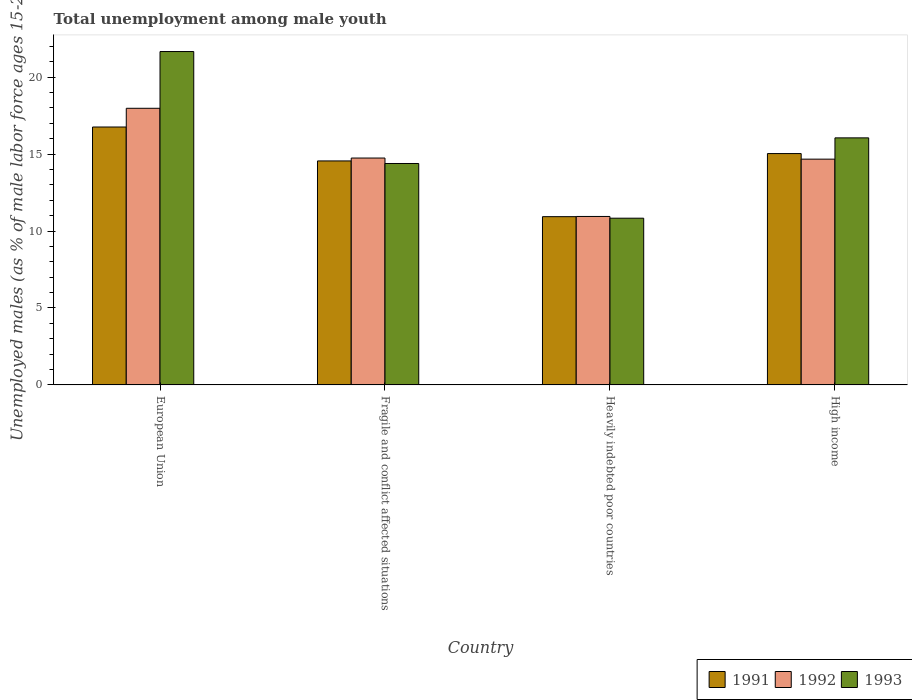How many different coloured bars are there?
Offer a very short reply. 3. Are the number of bars on each tick of the X-axis equal?
Your answer should be compact. Yes. What is the label of the 3rd group of bars from the left?
Make the answer very short. Heavily indebted poor countries. In how many cases, is the number of bars for a given country not equal to the number of legend labels?
Provide a succinct answer. 0. What is the percentage of unemployed males in in 1991 in Heavily indebted poor countries?
Give a very brief answer. 10.94. Across all countries, what is the maximum percentage of unemployed males in in 1991?
Provide a succinct answer. 16.76. Across all countries, what is the minimum percentage of unemployed males in in 1992?
Offer a terse response. 10.95. In which country was the percentage of unemployed males in in 1993 minimum?
Keep it short and to the point. Heavily indebted poor countries. What is the total percentage of unemployed males in in 1993 in the graph?
Offer a terse response. 62.96. What is the difference between the percentage of unemployed males in in 1993 in European Union and that in Heavily indebted poor countries?
Provide a short and direct response. 10.83. What is the difference between the percentage of unemployed males in in 1992 in High income and the percentage of unemployed males in in 1993 in Fragile and conflict affected situations?
Your answer should be compact. 0.28. What is the average percentage of unemployed males in in 1993 per country?
Ensure brevity in your answer.  15.74. What is the difference between the percentage of unemployed males in of/in 1992 and percentage of unemployed males in of/in 1991 in High income?
Offer a very short reply. -0.36. What is the ratio of the percentage of unemployed males in in 1991 in Fragile and conflict affected situations to that in Heavily indebted poor countries?
Offer a terse response. 1.33. Is the difference between the percentage of unemployed males in in 1992 in European Union and High income greater than the difference between the percentage of unemployed males in in 1991 in European Union and High income?
Your answer should be compact. Yes. What is the difference between the highest and the second highest percentage of unemployed males in in 1991?
Offer a very short reply. 2.2. What is the difference between the highest and the lowest percentage of unemployed males in in 1991?
Your answer should be compact. 5.83. In how many countries, is the percentage of unemployed males in in 1991 greater than the average percentage of unemployed males in in 1991 taken over all countries?
Ensure brevity in your answer.  3. Is the sum of the percentage of unemployed males in in 1993 in Fragile and conflict affected situations and High income greater than the maximum percentage of unemployed males in in 1991 across all countries?
Offer a terse response. Yes. What does the 3rd bar from the left in European Union represents?
Offer a very short reply. 1993. Is it the case that in every country, the sum of the percentage of unemployed males in in 1993 and percentage of unemployed males in in 1991 is greater than the percentage of unemployed males in in 1992?
Make the answer very short. Yes. Are all the bars in the graph horizontal?
Provide a short and direct response. No. What is the difference between two consecutive major ticks on the Y-axis?
Your answer should be very brief. 5. Where does the legend appear in the graph?
Give a very brief answer. Bottom right. How are the legend labels stacked?
Your answer should be compact. Horizontal. What is the title of the graph?
Your answer should be very brief. Total unemployment among male youth. What is the label or title of the X-axis?
Keep it short and to the point. Country. What is the label or title of the Y-axis?
Give a very brief answer. Unemployed males (as % of male labor force ages 15-24). What is the Unemployed males (as % of male labor force ages 15-24) of 1991 in European Union?
Offer a terse response. 16.76. What is the Unemployed males (as % of male labor force ages 15-24) of 1992 in European Union?
Your answer should be very brief. 17.98. What is the Unemployed males (as % of male labor force ages 15-24) in 1993 in European Union?
Provide a succinct answer. 21.67. What is the Unemployed males (as % of male labor force ages 15-24) in 1991 in Fragile and conflict affected situations?
Your answer should be compact. 14.56. What is the Unemployed males (as % of male labor force ages 15-24) of 1992 in Fragile and conflict affected situations?
Ensure brevity in your answer.  14.75. What is the Unemployed males (as % of male labor force ages 15-24) of 1993 in Fragile and conflict affected situations?
Ensure brevity in your answer.  14.39. What is the Unemployed males (as % of male labor force ages 15-24) of 1991 in Heavily indebted poor countries?
Your answer should be very brief. 10.94. What is the Unemployed males (as % of male labor force ages 15-24) of 1992 in Heavily indebted poor countries?
Provide a succinct answer. 10.95. What is the Unemployed males (as % of male labor force ages 15-24) in 1993 in Heavily indebted poor countries?
Offer a terse response. 10.84. What is the Unemployed males (as % of male labor force ages 15-24) of 1991 in High income?
Your answer should be compact. 15.04. What is the Unemployed males (as % of male labor force ages 15-24) in 1992 in High income?
Offer a terse response. 14.67. What is the Unemployed males (as % of male labor force ages 15-24) of 1993 in High income?
Provide a short and direct response. 16.06. Across all countries, what is the maximum Unemployed males (as % of male labor force ages 15-24) in 1991?
Make the answer very short. 16.76. Across all countries, what is the maximum Unemployed males (as % of male labor force ages 15-24) of 1992?
Your answer should be compact. 17.98. Across all countries, what is the maximum Unemployed males (as % of male labor force ages 15-24) of 1993?
Give a very brief answer. 21.67. Across all countries, what is the minimum Unemployed males (as % of male labor force ages 15-24) of 1991?
Provide a succinct answer. 10.94. Across all countries, what is the minimum Unemployed males (as % of male labor force ages 15-24) in 1992?
Keep it short and to the point. 10.95. Across all countries, what is the minimum Unemployed males (as % of male labor force ages 15-24) of 1993?
Your response must be concise. 10.84. What is the total Unemployed males (as % of male labor force ages 15-24) in 1991 in the graph?
Provide a succinct answer. 57.3. What is the total Unemployed males (as % of male labor force ages 15-24) of 1992 in the graph?
Ensure brevity in your answer.  58.35. What is the total Unemployed males (as % of male labor force ages 15-24) of 1993 in the graph?
Your answer should be very brief. 62.96. What is the difference between the Unemployed males (as % of male labor force ages 15-24) of 1991 in European Union and that in Fragile and conflict affected situations?
Offer a terse response. 2.2. What is the difference between the Unemployed males (as % of male labor force ages 15-24) in 1992 in European Union and that in Fragile and conflict affected situations?
Your answer should be very brief. 3.23. What is the difference between the Unemployed males (as % of male labor force ages 15-24) of 1993 in European Union and that in Fragile and conflict affected situations?
Your response must be concise. 7.28. What is the difference between the Unemployed males (as % of male labor force ages 15-24) of 1991 in European Union and that in Heavily indebted poor countries?
Your answer should be very brief. 5.83. What is the difference between the Unemployed males (as % of male labor force ages 15-24) of 1992 in European Union and that in Heavily indebted poor countries?
Offer a terse response. 7.03. What is the difference between the Unemployed males (as % of male labor force ages 15-24) of 1993 in European Union and that in Heavily indebted poor countries?
Give a very brief answer. 10.83. What is the difference between the Unemployed males (as % of male labor force ages 15-24) in 1991 in European Union and that in High income?
Keep it short and to the point. 1.73. What is the difference between the Unemployed males (as % of male labor force ages 15-24) in 1992 in European Union and that in High income?
Your answer should be very brief. 3.31. What is the difference between the Unemployed males (as % of male labor force ages 15-24) in 1993 in European Union and that in High income?
Make the answer very short. 5.61. What is the difference between the Unemployed males (as % of male labor force ages 15-24) of 1991 in Fragile and conflict affected situations and that in Heavily indebted poor countries?
Your answer should be very brief. 3.62. What is the difference between the Unemployed males (as % of male labor force ages 15-24) of 1992 in Fragile and conflict affected situations and that in Heavily indebted poor countries?
Provide a succinct answer. 3.8. What is the difference between the Unemployed males (as % of male labor force ages 15-24) of 1993 in Fragile and conflict affected situations and that in Heavily indebted poor countries?
Your answer should be very brief. 3.56. What is the difference between the Unemployed males (as % of male labor force ages 15-24) of 1991 in Fragile and conflict affected situations and that in High income?
Your response must be concise. -0.48. What is the difference between the Unemployed males (as % of male labor force ages 15-24) in 1992 in Fragile and conflict affected situations and that in High income?
Your response must be concise. 0.07. What is the difference between the Unemployed males (as % of male labor force ages 15-24) in 1993 in Fragile and conflict affected situations and that in High income?
Provide a succinct answer. -1.67. What is the difference between the Unemployed males (as % of male labor force ages 15-24) in 1991 in Heavily indebted poor countries and that in High income?
Offer a very short reply. -4.1. What is the difference between the Unemployed males (as % of male labor force ages 15-24) in 1992 in Heavily indebted poor countries and that in High income?
Ensure brevity in your answer.  -3.72. What is the difference between the Unemployed males (as % of male labor force ages 15-24) of 1993 in Heavily indebted poor countries and that in High income?
Provide a succinct answer. -5.22. What is the difference between the Unemployed males (as % of male labor force ages 15-24) in 1991 in European Union and the Unemployed males (as % of male labor force ages 15-24) in 1992 in Fragile and conflict affected situations?
Provide a succinct answer. 2.02. What is the difference between the Unemployed males (as % of male labor force ages 15-24) of 1991 in European Union and the Unemployed males (as % of male labor force ages 15-24) of 1993 in Fragile and conflict affected situations?
Provide a succinct answer. 2.37. What is the difference between the Unemployed males (as % of male labor force ages 15-24) in 1992 in European Union and the Unemployed males (as % of male labor force ages 15-24) in 1993 in Fragile and conflict affected situations?
Your response must be concise. 3.59. What is the difference between the Unemployed males (as % of male labor force ages 15-24) of 1991 in European Union and the Unemployed males (as % of male labor force ages 15-24) of 1992 in Heavily indebted poor countries?
Offer a very short reply. 5.81. What is the difference between the Unemployed males (as % of male labor force ages 15-24) of 1991 in European Union and the Unemployed males (as % of male labor force ages 15-24) of 1993 in Heavily indebted poor countries?
Your answer should be very brief. 5.93. What is the difference between the Unemployed males (as % of male labor force ages 15-24) of 1992 in European Union and the Unemployed males (as % of male labor force ages 15-24) of 1993 in Heavily indebted poor countries?
Provide a short and direct response. 7.14. What is the difference between the Unemployed males (as % of male labor force ages 15-24) of 1991 in European Union and the Unemployed males (as % of male labor force ages 15-24) of 1992 in High income?
Make the answer very short. 2.09. What is the difference between the Unemployed males (as % of male labor force ages 15-24) in 1991 in European Union and the Unemployed males (as % of male labor force ages 15-24) in 1993 in High income?
Make the answer very short. 0.71. What is the difference between the Unemployed males (as % of male labor force ages 15-24) in 1992 in European Union and the Unemployed males (as % of male labor force ages 15-24) in 1993 in High income?
Provide a short and direct response. 1.92. What is the difference between the Unemployed males (as % of male labor force ages 15-24) of 1991 in Fragile and conflict affected situations and the Unemployed males (as % of male labor force ages 15-24) of 1992 in Heavily indebted poor countries?
Your answer should be very brief. 3.61. What is the difference between the Unemployed males (as % of male labor force ages 15-24) in 1991 in Fragile and conflict affected situations and the Unemployed males (as % of male labor force ages 15-24) in 1993 in Heavily indebted poor countries?
Your answer should be very brief. 3.72. What is the difference between the Unemployed males (as % of male labor force ages 15-24) of 1992 in Fragile and conflict affected situations and the Unemployed males (as % of male labor force ages 15-24) of 1993 in Heavily indebted poor countries?
Provide a succinct answer. 3.91. What is the difference between the Unemployed males (as % of male labor force ages 15-24) in 1991 in Fragile and conflict affected situations and the Unemployed males (as % of male labor force ages 15-24) in 1992 in High income?
Your answer should be compact. -0.12. What is the difference between the Unemployed males (as % of male labor force ages 15-24) of 1991 in Fragile and conflict affected situations and the Unemployed males (as % of male labor force ages 15-24) of 1993 in High income?
Ensure brevity in your answer.  -1.5. What is the difference between the Unemployed males (as % of male labor force ages 15-24) of 1992 in Fragile and conflict affected situations and the Unemployed males (as % of male labor force ages 15-24) of 1993 in High income?
Ensure brevity in your answer.  -1.31. What is the difference between the Unemployed males (as % of male labor force ages 15-24) of 1991 in Heavily indebted poor countries and the Unemployed males (as % of male labor force ages 15-24) of 1992 in High income?
Keep it short and to the point. -3.74. What is the difference between the Unemployed males (as % of male labor force ages 15-24) of 1991 in Heavily indebted poor countries and the Unemployed males (as % of male labor force ages 15-24) of 1993 in High income?
Give a very brief answer. -5.12. What is the difference between the Unemployed males (as % of male labor force ages 15-24) in 1992 in Heavily indebted poor countries and the Unemployed males (as % of male labor force ages 15-24) in 1993 in High income?
Ensure brevity in your answer.  -5.11. What is the average Unemployed males (as % of male labor force ages 15-24) in 1991 per country?
Your answer should be compact. 14.32. What is the average Unemployed males (as % of male labor force ages 15-24) of 1992 per country?
Provide a succinct answer. 14.59. What is the average Unemployed males (as % of male labor force ages 15-24) of 1993 per country?
Your answer should be very brief. 15.74. What is the difference between the Unemployed males (as % of male labor force ages 15-24) of 1991 and Unemployed males (as % of male labor force ages 15-24) of 1992 in European Union?
Keep it short and to the point. -1.22. What is the difference between the Unemployed males (as % of male labor force ages 15-24) in 1991 and Unemployed males (as % of male labor force ages 15-24) in 1993 in European Union?
Ensure brevity in your answer.  -4.91. What is the difference between the Unemployed males (as % of male labor force ages 15-24) in 1992 and Unemployed males (as % of male labor force ages 15-24) in 1993 in European Union?
Ensure brevity in your answer.  -3.69. What is the difference between the Unemployed males (as % of male labor force ages 15-24) in 1991 and Unemployed males (as % of male labor force ages 15-24) in 1992 in Fragile and conflict affected situations?
Your response must be concise. -0.19. What is the difference between the Unemployed males (as % of male labor force ages 15-24) in 1991 and Unemployed males (as % of male labor force ages 15-24) in 1993 in Fragile and conflict affected situations?
Offer a terse response. 0.17. What is the difference between the Unemployed males (as % of male labor force ages 15-24) in 1992 and Unemployed males (as % of male labor force ages 15-24) in 1993 in Fragile and conflict affected situations?
Offer a very short reply. 0.36. What is the difference between the Unemployed males (as % of male labor force ages 15-24) in 1991 and Unemployed males (as % of male labor force ages 15-24) in 1992 in Heavily indebted poor countries?
Provide a succinct answer. -0.01. What is the difference between the Unemployed males (as % of male labor force ages 15-24) in 1991 and Unemployed males (as % of male labor force ages 15-24) in 1993 in Heavily indebted poor countries?
Your answer should be compact. 0.1. What is the difference between the Unemployed males (as % of male labor force ages 15-24) in 1992 and Unemployed males (as % of male labor force ages 15-24) in 1993 in Heavily indebted poor countries?
Offer a very short reply. 0.11. What is the difference between the Unemployed males (as % of male labor force ages 15-24) of 1991 and Unemployed males (as % of male labor force ages 15-24) of 1992 in High income?
Make the answer very short. 0.36. What is the difference between the Unemployed males (as % of male labor force ages 15-24) of 1991 and Unemployed males (as % of male labor force ages 15-24) of 1993 in High income?
Offer a terse response. -1.02. What is the difference between the Unemployed males (as % of male labor force ages 15-24) of 1992 and Unemployed males (as % of male labor force ages 15-24) of 1993 in High income?
Make the answer very short. -1.38. What is the ratio of the Unemployed males (as % of male labor force ages 15-24) of 1991 in European Union to that in Fragile and conflict affected situations?
Give a very brief answer. 1.15. What is the ratio of the Unemployed males (as % of male labor force ages 15-24) of 1992 in European Union to that in Fragile and conflict affected situations?
Provide a short and direct response. 1.22. What is the ratio of the Unemployed males (as % of male labor force ages 15-24) of 1993 in European Union to that in Fragile and conflict affected situations?
Provide a succinct answer. 1.51. What is the ratio of the Unemployed males (as % of male labor force ages 15-24) in 1991 in European Union to that in Heavily indebted poor countries?
Offer a very short reply. 1.53. What is the ratio of the Unemployed males (as % of male labor force ages 15-24) in 1992 in European Union to that in Heavily indebted poor countries?
Offer a very short reply. 1.64. What is the ratio of the Unemployed males (as % of male labor force ages 15-24) of 1993 in European Union to that in Heavily indebted poor countries?
Offer a terse response. 2. What is the ratio of the Unemployed males (as % of male labor force ages 15-24) of 1991 in European Union to that in High income?
Provide a succinct answer. 1.11. What is the ratio of the Unemployed males (as % of male labor force ages 15-24) of 1992 in European Union to that in High income?
Offer a very short reply. 1.23. What is the ratio of the Unemployed males (as % of male labor force ages 15-24) in 1993 in European Union to that in High income?
Offer a very short reply. 1.35. What is the ratio of the Unemployed males (as % of male labor force ages 15-24) of 1991 in Fragile and conflict affected situations to that in Heavily indebted poor countries?
Provide a succinct answer. 1.33. What is the ratio of the Unemployed males (as % of male labor force ages 15-24) of 1992 in Fragile and conflict affected situations to that in Heavily indebted poor countries?
Make the answer very short. 1.35. What is the ratio of the Unemployed males (as % of male labor force ages 15-24) of 1993 in Fragile and conflict affected situations to that in Heavily indebted poor countries?
Ensure brevity in your answer.  1.33. What is the ratio of the Unemployed males (as % of male labor force ages 15-24) in 1991 in Fragile and conflict affected situations to that in High income?
Offer a terse response. 0.97. What is the ratio of the Unemployed males (as % of male labor force ages 15-24) of 1992 in Fragile and conflict affected situations to that in High income?
Ensure brevity in your answer.  1. What is the ratio of the Unemployed males (as % of male labor force ages 15-24) of 1993 in Fragile and conflict affected situations to that in High income?
Ensure brevity in your answer.  0.9. What is the ratio of the Unemployed males (as % of male labor force ages 15-24) in 1991 in Heavily indebted poor countries to that in High income?
Ensure brevity in your answer.  0.73. What is the ratio of the Unemployed males (as % of male labor force ages 15-24) in 1992 in Heavily indebted poor countries to that in High income?
Offer a terse response. 0.75. What is the ratio of the Unemployed males (as % of male labor force ages 15-24) of 1993 in Heavily indebted poor countries to that in High income?
Give a very brief answer. 0.67. What is the difference between the highest and the second highest Unemployed males (as % of male labor force ages 15-24) of 1991?
Offer a very short reply. 1.73. What is the difference between the highest and the second highest Unemployed males (as % of male labor force ages 15-24) in 1992?
Offer a terse response. 3.23. What is the difference between the highest and the second highest Unemployed males (as % of male labor force ages 15-24) of 1993?
Give a very brief answer. 5.61. What is the difference between the highest and the lowest Unemployed males (as % of male labor force ages 15-24) in 1991?
Offer a very short reply. 5.83. What is the difference between the highest and the lowest Unemployed males (as % of male labor force ages 15-24) in 1992?
Your answer should be very brief. 7.03. What is the difference between the highest and the lowest Unemployed males (as % of male labor force ages 15-24) of 1993?
Ensure brevity in your answer.  10.83. 